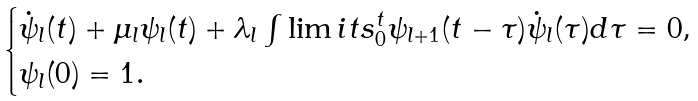<formula> <loc_0><loc_0><loc_500><loc_500>\begin{cases} \dot { \psi } _ { l } ( t ) + \mu _ { l } \psi _ { l } ( t ) + \lambda _ { l } \int \lim i t s _ { 0 } ^ { t } \psi _ { l + 1 } ( t - \tau ) \dot { \psi } _ { l } ( \tau ) d \tau = 0 , \\ \psi _ { l } ( 0 ) = 1 . \end{cases}</formula> 